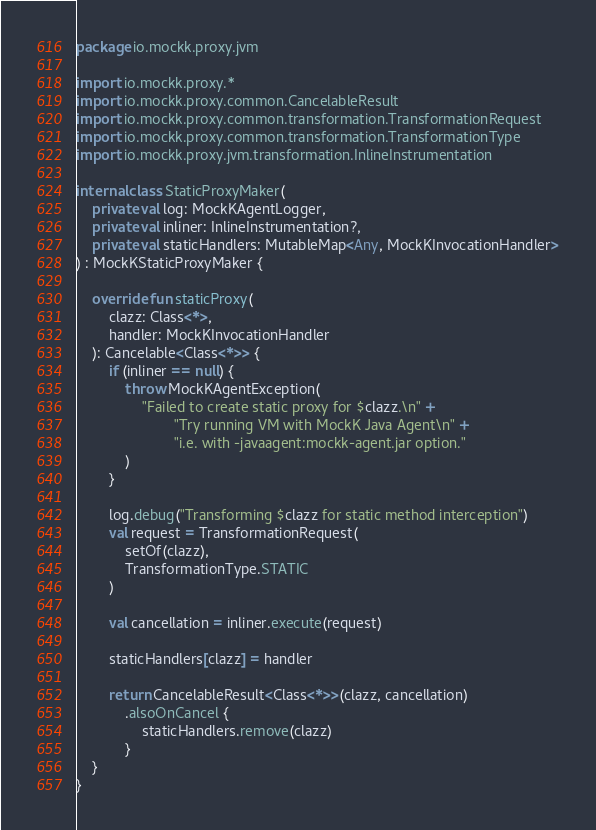Convert code to text. <code><loc_0><loc_0><loc_500><loc_500><_Kotlin_>package io.mockk.proxy.jvm

import io.mockk.proxy.*
import io.mockk.proxy.common.CancelableResult
import io.mockk.proxy.common.transformation.TransformationRequest
import io.mockk.proxy.common.transformation.TransformationType
import io.mockk.proxy.jvm.transformation.InlineInstrumentation

internal class StaticProxyMaker(
    private val log: MockKAgentLogger,
    private val inliner: InlineInstrumentation?,
    private val staticHandlers: MutableMap<Any, MockKInvocationHandler>
) : MockKStaticProxyMaker {

    override fun staticProxy(
        clazz: Class<*>,
        handler: MockKInvocationHandler
    ): Cancelable<Class<*>> {
        if (inliner == null) {
            throw MockKAgentException(
                "Failed to create static proxy for $clazz.\n" +
                        "Try running VM with MockK Java Agent\n" +
                        "i.e. with -javaagent:mockk-agent.jar option."
            )
        }

        log.debug("Transforming $clazz for static method interception")
        val request = TransformationRequest(
            setOf(clazz),
            TransformationType.STATIC
        )

        val cancellation = inliner.execute(request)

        staticHandlers[clazz] = handler

        return CancelableResult<Class<*>>(clazz, cancellation)
            .alsoOnCancel {
                staticHandlers.remove(clazz)
            }
    }
}
</code> 